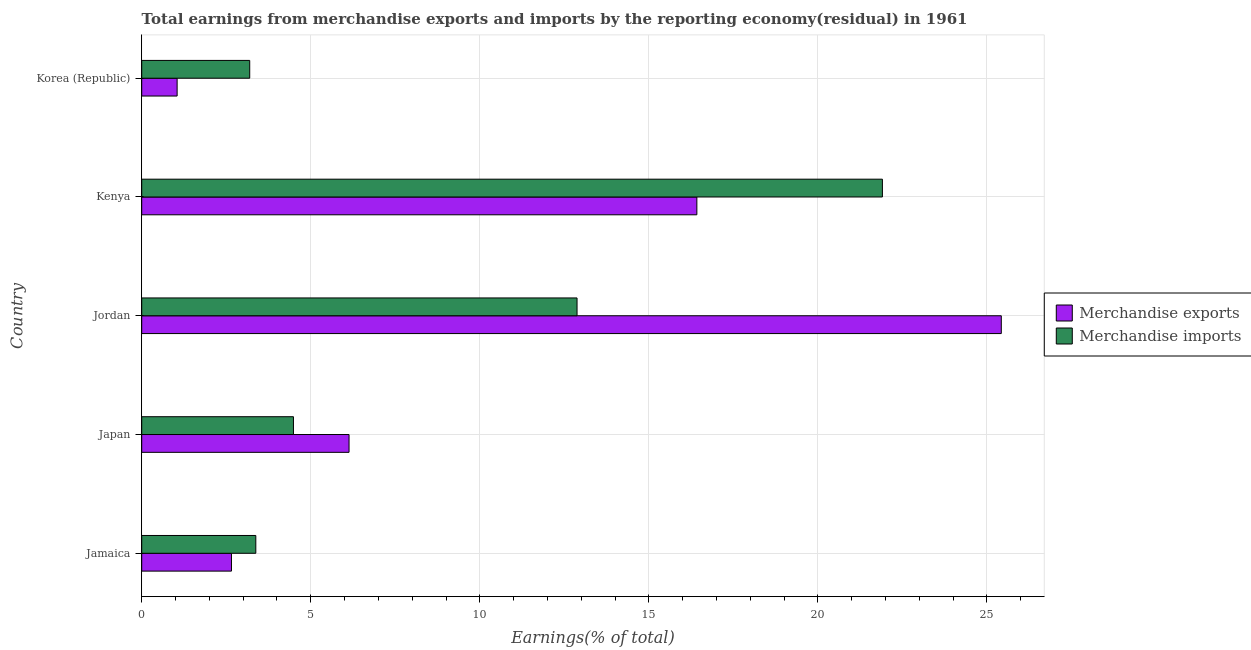How many different coloured bars are there?
Your response must be concise. 2. How many groups of bars are there?
Provide a succinct answer. 5. Are the number of bars per tick equal to the number of legend labels?
Your response must be concise. Yes. Are the number of bars on each tick of the Y-axis equal?
Your answer should be very brief. Yes. How many bars are there on the 2nd tick from the top?
Your answer should be compact. 2. How many bars are there on the 1st tick from the bottom?
Keep it short and to the point. 2. What is the label of the 2nd group of bars from the top?
Your response must be concise. Kenya. What is the earnings from merchandise imports in Jamaica?
Your answer should be very brief. 3.37. Across all countries, what is the maximum earnings from merchandise imports?
Provide a succinct answer. 21.91. Across all countries, what is the minimum earnings from merchandise exports?
Keep it short and to the point. 1.05. In which country was the earnings from merchandise exports maximum?
Your response must be concise. Jordan. In which country was the earnings from merchandise exports minimum?
Keep it short and to the point. Korea (Republic). What is the total earnings from merchandise imports in the graph?
Make the answer very short. 45.84. What is the difference between the earnings from merchandise imports in Jamaica and that in Kenya?
Your answer should be compact. -18.53. What is the difference between the earnings from merchandise exports in Korea (Republic) and the earnings from merchandise imports in Jordan?
Your answer should be compact. -11.83. What is the average earnings from merchandise exports per country?
Provide a short and direct response. 10.34. What is the difference between the earnings from merchandise exports and earnings from merchandise imports in Jamaica?
Provide a succinct answer. -0.72. In how many countries, is the earnings from merchandise imports greater than 17 %?
Your answer should be very brief. 1. What is the ratio of the earnings from merchandise imports in Jamaica to that in Japan?
Your response must be concise. 0.75. Is the earnings from merchandise exports in Japan less than that in Korea (Republic)?
Provide a short and direct response. No. What is the difference between the highest and the second highest earnings from merchandise exports?
Offer a very short reply. 9.01. What is the difference between the highest and the lowest earnings from merchandise imports?
Keep it short and to the point. 18.71. In how many countries, is the earnings from merchandise exports greater than the average earnings from merchandise exports taken over all countries?
Your answer should be very brief. 2. Is the sum of the earnings from merchandise exports in Jamaica and Korea (Republic) greater than the maximum earnings from merchandise imports across all countries?
Ensure brevity in your answer.  No. How many countries are there in the graph?
Your response must be concise. 5. What is the difference between two consecutive major ticks on the X-axis?
Give a very brief answer. 5. Are the values on the major ticks of X-axis written in scientific E-notation?
Offer a very short reply. No. Does the graph contain any zero values?
Give a very brief answer. No. Does the graph contain grids?
Ensure brevity in your answer.  Yes. Where does the legend appear in the graph?
Give a very brief answer. Center right. What is the title of the graph?
Give a very brief answer. Total earnings from merchandise exports and imports by the reporting economy(residual) in 1961. Does "% of gross capital formation" appear as one of the legend labels in the graph?
Keep it short and to the point. No. What is the label or title of the X-axis?
Keep it short and to the point. Earnings(% of total). What is the label or title of the Y-axis?
Offer a very short reply. Country. What is the Earnings(% of total) of Merchandise exports in Jamaica?
Provide a short and direct response. 2.65. What is the Earnings(% of total) of Merchandise imports in Jamaica?
Ensure brevity in your answer.  3.37. What is the Earnings(% of total) in Merchandise exports in Japan?
Make the answer very short. 6.13. What is the Earnings(% of total) of Merchandise imports in Japan?
Provide a short and direct response. 4.49. What is the Earnings(% of total) in Merchandise exports in Jordan?
Ensure brevity in your answer.  25.42. What is the Earnings(% of total) of Merchandise imports in Jordan?
Provide a short and direct response. 12.88. What is the Earnings(% of total) in Merchandise exports in Kenya?
Provide a short and direct response. 16.42. What is the Earnings(% of total) of Merchandise imports in Kenya?
Provide a short and direct response. 21.91. What is the Earnings(% of total) of Merchandise exports in Korea (Republic)?
Your answer should be compact. 1.05. What is the Earnings(% of total) of Merchandise imports in Korea (Republic)?
Your response must be concise. 3.19. Across all countries, what is the maximum Earnings(% of total) in Merchandise exports?
Provide a short and direct response. 25.42. Across all countries, what is the maximum Earnings(% of total) of Merchandise imports?
Keep it short and to the point. 21.91. Across all countries, what is the minimum Earnings(% of total) in Merchandise exports?
Keep it short and to the point. 1.05. Across all countries, what is the minimum Earnings(% of total) of Merchandise imports?
Your response must be concise. 3.19. What is the total Earnings(% of total) in Merchandise exports in the graph?
Make the answer very short. 51.68. What is the total Earnings(% of total) of Merchandise imports in the graph?
Your response must be concise. 45.84. What is the difference between the Earnings(% of total) of Merchandise exports in Jamaica and that in Japan?
Give a very brief answer. -3.48. What is the difference between the Earnings(% of total) of Merchandise imports in Jamaica and that in Japan?
Your response must be concise. -1.11. What is the difference between the Earnings(% of total) in Merchandise exports in Jamaica and that in Jordan?
Your answer should be very brief. -22.77. What is the difference between the Earnings(% of total) of Merchandise imports in Jamaica and that in Jordan?
Make the answer very short. -9.5. What is the difference between the Earnings(% of total) in Merchandise exports in Jamaica and that in Kenya?
Ensure brevity in your answer.  -13.76. What is the difference between the Earnings(% of total) in Merchandise imports in Jamaica and that in Kenya?
Provide a succinct answer. -18.53. What is the difference between the Earnings(% of total) of Merchandise exports in Jamaica and that in Korea (Republic)?
Your answer should be very brief. 1.61. What is the difference between the Earnings(% of total) of Merchandise imports in Jamaica and that in Korea (Republic)?
Make the answer very short. 0.18. What is the difference between the Earnings(% of total) in Merchandise exports in Japan and that in Jordan?
Give a very brief answer. -19.29. What is the difference between the Earnings(% of total) of Merchandise imports in Japan and that in Jordan?
Provide a short and direct response. -8.39. What is the difference between the Earnings(% of total) of Merchandise exports in Japan and that in Kenya?
Provide a succinct answer. -10.29. What is the difference between the Earnings(% of total) in Merchandise imports in Japan and that in Kenya?
Provide a succinct answer. -17.42. What is the difference between the Earnings(% of total) in Merchandise exports in Japan and that in Korea (Republic)?
Offer a very short reply. 5.08. What is the difference between the Earnings(% of total) in Merchandise imports in Japan and that in Korea (Republic)?
Provide a succinct answer. 1.29. What is the difference between the Earnings(% of total) of Merchandise exports in Jordan and that in Kenya?
Make the answer very short. 9. What is the difference between the Earnings(% of total) of Merchandise imports in Jordan and that in Kenya?
Ensure brevity in your answer.  -9.03. What is the difference between the Earnings(% of total) in Merchandise exports in Jordan and that in Korea (Republic)?
Provide a short and direct response. 24.38. What is the difference between the Earnings(% of total) of Merchandise imports in Jordan and that in Korea (Republic)?
Make the answer very short. 9.68. What is the difference between the Earnings(% of total) of Merchandise exports in Kenya and that in Korea (Republic)?
Offer a terse response. 15.37. What is the difference between the Earnings(% of total) of Merchandise imports in Kenya and that in Korea (Republic)?
Offer a terse response. 18.71. What is the difference between the Earnings(% of total) of Merchandise exports in Jamaica and the Earnings(% of total) of Merchandise imports in Japan?
Give a very brief answer. -1.83. What is the difference between the Earnings(% of total) in Merchandise exports in Jamaica and the Earnings(% of total) in Merchandise imports in Jordan?
Your response must be concise. -10.22. What is the difference between the Earnings(% of total) in Merchandise exports in Jamaica and the Earnings(% of total) in Merchandise imports in Kenya?
Your answer should be very brief. -19.25. What is the difference between the Earnings(% of total) in Merchandise exports in Jamaica and the Earnings(% of total) in Merchandise imports in Korea (Republic)?
Provide a succinct answer. -0.54. What is the difference between the Earnings(% of total) of Merchandise exports in Japan and the Earnings(% of total) of Merchandise imports in Jordan?
Ensure brevity in your answer.  -6.74. What is the difference between the Earnings(% of total) in Merchandise exports in Japan and the Earnings(% of total) in Merchandise imports in Kenya?
Your response must be concise. -15.78. What is the difference between the Earnings(% of total) in Merchandise exports in Japan and the Earnings(% of total) in Merchandise imports in Korea (Republic)?
Provide a short and direct response. 2.94. What is the difference between the Earnings(% of total) in Merchandise exports in Jordan and the Earnings(% of total) in Merchandise imports in Kenya?
Ensure brevity in your answer.  3.52. What is the difference between the Earnings(% of total) in Merchandise exports in Jordan and the Earnings(% of total) in Merchandise imports in Korea (Republic)?
Your answer should be compact. 22.23. What is the difference between the Earnings(% of total) of Merchandise exports in Kenya and the Earnings(% of total) of Merchandise imports in Korea (Republic)?
Offer a very short reply. 13.22. What is the average Earnings(% of total) of Merchandise exports per country?
Ensure brevity in your answer.  10.34. What is the average Earnings(% of total) of Merchandise imports per country?
Ensure brevity in your answer.  9.17. What is the difference between the Earnings(% of total) in Merchandise exports and Earnings(% of total) in Merchandise imports in Jamaica?
Your answer should be compact. -0.72. What is the difference between the Earnings(% of total) of Merchandise exports and Earnings(% of total) of Merchandise imports in Japan?
Your answer should be very brief. 1.64. What is the difference between the Earnings(% of total) of Merchandise exports and Earnings(% of total) of Merchandise imports in Jordan?
Keep it short and to the point. 12.55. What is the difference between the Earnings(% of total) in Merchandise exports and Earnings(% of total) in Merchandise imports in Kenya?
Offer a very short reply. -5.49. What is the difference between the Earnings(% of total) of Merchandise exports and Earnings(% of total) of Merchandise imports in Korea (Republic)?
Provide a short and direct response. -2.15. What is the ratio of the Earnings(% of total) in Merchandise exports in Jamaica to that in Japan?
Make the answer very short. 0.43. What is the ratio of the Earnings(% of total) in Merchandise imports in Jamaica to that in Japan?
Offer a very short reply. 0.75. What is the ratio of the Earnings(% of total) in Merchandise exports in Jamaica to that in Jordan?
Provide a succinct answer. 0.1. What is the ratio of the Earnings(% of total) in Merchandise imports in Jamaica to that in Jordan?
Your answer should be compact. 0.26. What is the ratio of the Earnings(% of total) in Merchandise exports in Jamaica to that in Kenya?
Keep it short and to the point. 0.16. What is the ratio of the Earnings(% of total) of Merchandise imports in Jamaica to that in Kenya?
Ensure brevity in your answer.  0.15. What is the ratio of the Earnings(% of total) in Merchandise exports in Jamaica to that in Korea (Republic)?
Provide a short and direct response. 2.53. What is the ratio of the Earnings(% of total) in Merchandise imports in Jamaica to that in Korea (Republic)?
Ensure brevity in your answer.  1.06. What is the ratio of the Earnings(% of total) of Merchandise exports in Japan to that in Jordan?
Provide a succinct answer. 0.24. What is the ratio of the Earnings(% of total) in Merchandise imports in Japan to that in Jordan?
Your answer should be compact. 0.35. What is the ratio of the Earnings(% of total) of Merchandise exports in Japan to that in Kenya?
Provide a short and direct response. 0.37. What is the ratio of the Earnings(% of total) of Merchandise imports in Japan to that in Kenya?
Provide a succinct answer. 0.2. What is the ratio of the Earnings(% of total) of Merchandise exports in Japan to that in Korea (Republic)?
Give a very brief answer. 5.86. What is the ratio of the Earnings(% of total) in Merchandise imports in Japan to that in Korea (Republic)?
Provide a short and direct response. 1.41. What is the ratio of the Earnings(% of total) of Merchandise exports in Jordan to that in Kenya?
Offer a very short reply. 1.55. What is the ratio of the Earnings(% of total) in Merchandise imports in Jordan to that in Kenya?
Offer a very short reply. 0.59. What is the ratio of the Earnings(% of total) in Merchandise exports in Jordan to that in Korea (Republic)?
Your answer should be very brief. 24.28. What is the ratio of the Earnings(% of total) of Merchandise imports in Jordan to that in Korea (Republic)?
Offer a terse response. 4.03. What is the ratio of the Earnings(% of total) in Merchandise exports in Kenya to that in Korea (Republic)?
Your answer should be compact. 15.68. What is the ratio of the Earnings(% of total) of Merchandise imports in Kenya to that in Korea (Republic)?
Your answer should be very brief. 6.86. What is the difference between the highest and the second highest Earnings(% of total) in Merchandise exports?
Keep it short and to the point. 9. What is the difference between the highest and the second highest Earnings(% of total) of Merchandise imports?
Offer a very short reply. 9.03. What is the difference between the highest and the lowest Earnings(% of total) in Merchandise exports?
Provide a short and direct response. 24.38. What is the difference between the highest and the lowest Earnings(% of total) in Merchandise imports?
Your answer should be very brief. 18.71. 